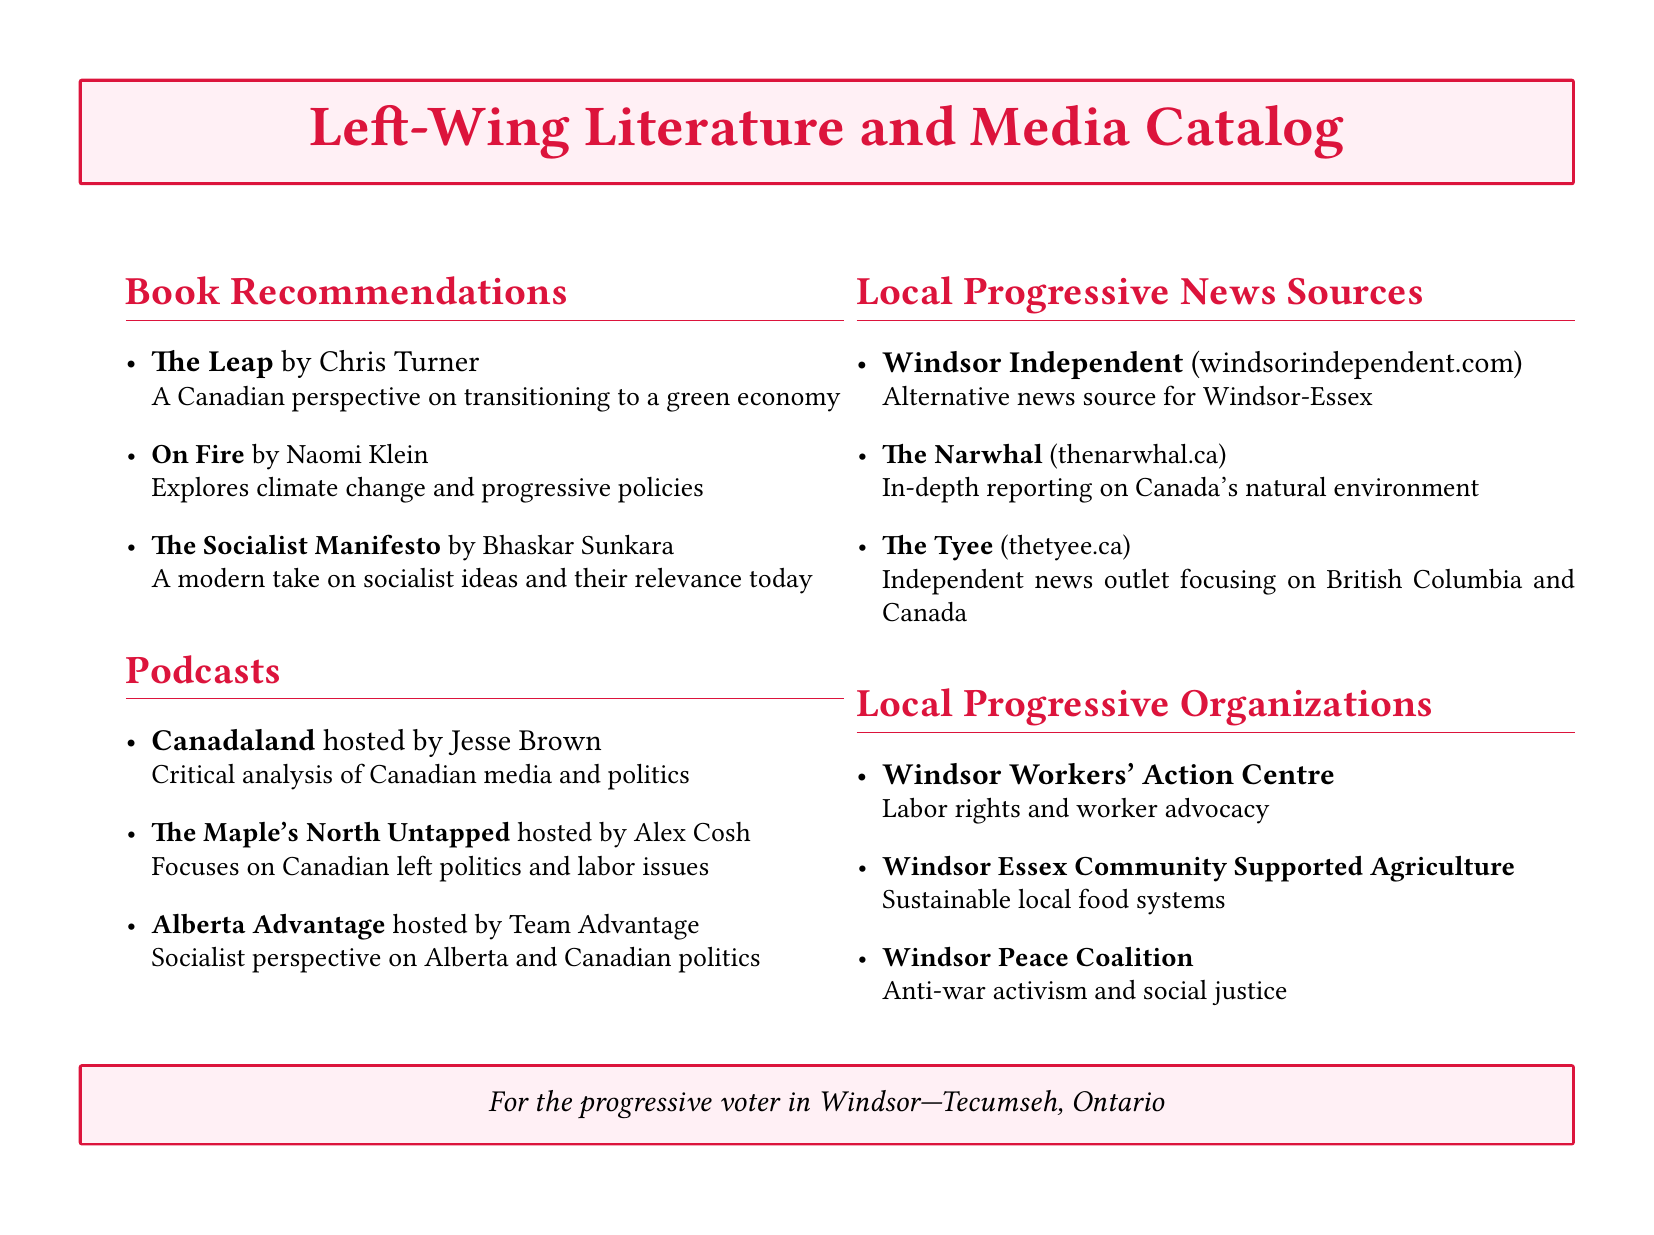What is the title of Naomi Klein's book? The document mentions "On Fire" by Naomi Klein as a book recommendation.
Answer: On Fire Who hosts the podcast "Canadaland"? The document states that "Canadaland" is hosted by Jesse Brown.
Answer: Jesse Brown What is the focus of "The Maple's North Untapped"? The document describes "The Maple's North Untapped" as focusing on Canadian left politics and labor issues.
Answer: Canadian left politics and labor issues Name one local progressive news source listed. The document lists several sources, and one example is the "Windsor Independent."
Answer: Windsor Independent What is the purpose of the Windsor Workers' Action Centre? The document explains that the Windsor Workers' Action Centre focuses on labor rights and worker advocacy.
Answer: Labor rights and worker advocacy How many book recommendations are provided in the catalog? The document lists three book recommendations in the "Book Recommendations" section.
Answer: 3 What type of activism does the Windsor Peace Coalition focus on? The document states that the Windsor Peace Coalition is focused on anti-war activism and social justice.
Answer: Anti-war activism and social justice Which organization promotes sustainable local food systems? According to the document, the Windsor Essex Community Supported Agriculture promotes sustainable local food systems.
Answer: Windsor Essex Community Supported Agriculture 